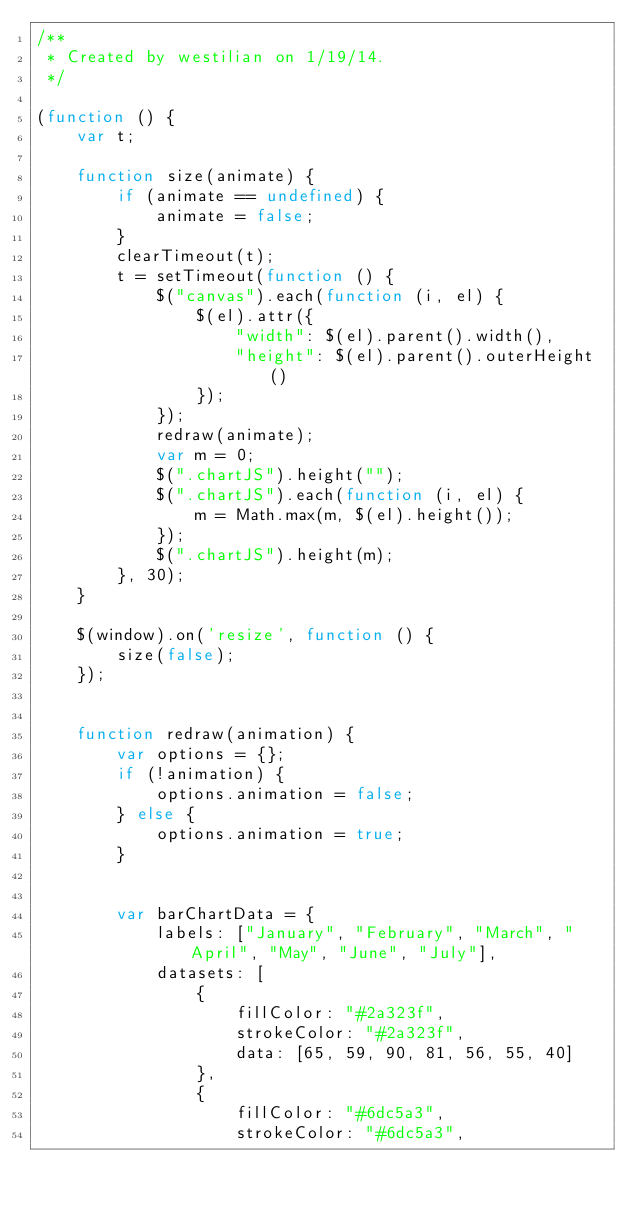<code> <loc_0><loc_0><loc_500><loc_500><_JavaScript_>/**
 * Created by westilian on 1/19/14.
 */

(function () {
    var t;

    function size(animate) {
        if (animate == undefined) {
            animate = false;
        }
        clearTimeout(t);
        t = setTimeout(function () {
            $("canvas").each(function (i, el) {
                $(el).attr({
                    "width": $(el).parent().width(),
                    "height": $(el).parent().outerHeight()
                });
            });
            redraw(animate);
            var m = 0;
            $(".chartJS").height("");
            $(".chartJS").each(function (i, el) {
                m = Math.max(m, $(el).height());
            });
            $(".chartJS").height(m);
        }, 30);
    }

    $(window).on('resize', function () {
        size(false);
    });


    function redraw(animation) {
        var options = {};
        if (!animation) {
            options.animation = false;
        } else {
            options.animation = true;
        }


        var barChartData = {
            labels: ["January", "February", "March", "April", "May", "June", "July"],
            datasets: [
                {
                    fillColor: "#2a323f",
                    strokeColor: "#2a323f",
                    data: [65, 59, 90, 81, 56, 55, 40]
                },
                {
                    fillColor: "#6dc5a3",
                    strokeColor: "#6dc5a3",</code> 